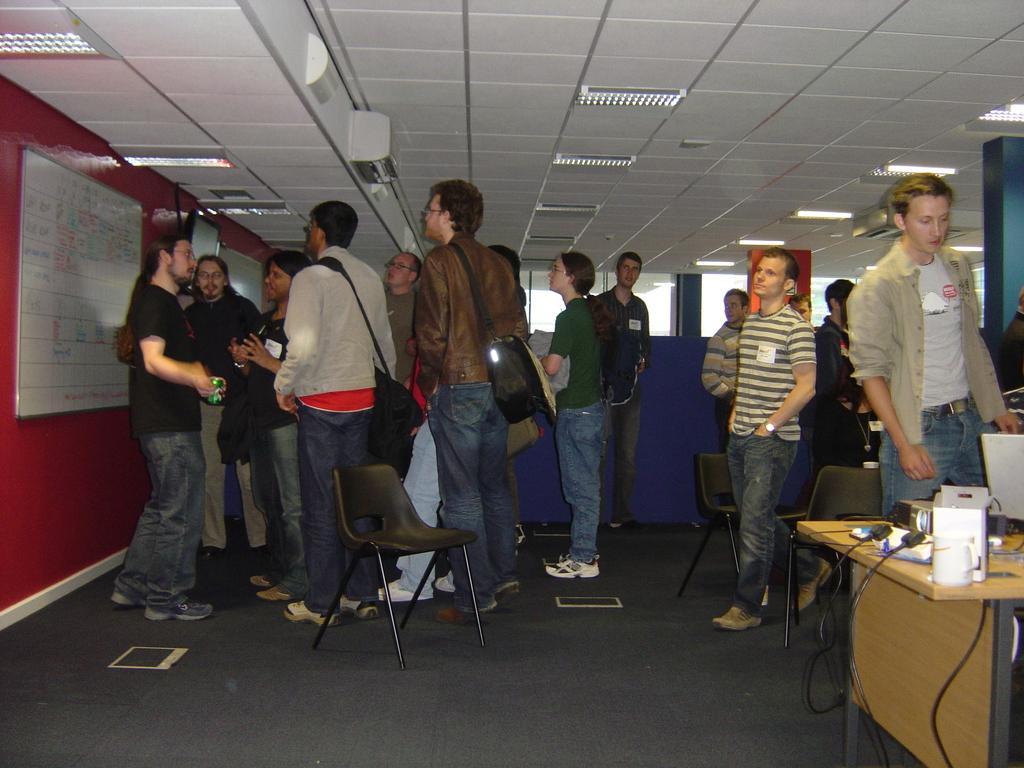Could you give a brief overview of what you see in this image? In this image I see number of people and I see the black chairs and I see a table over here on which there are few things and I see the wires and I see the floor. In the background I see the red wall on which there is a board and I see a screen over here and I see the ceiling on which there are lights. 